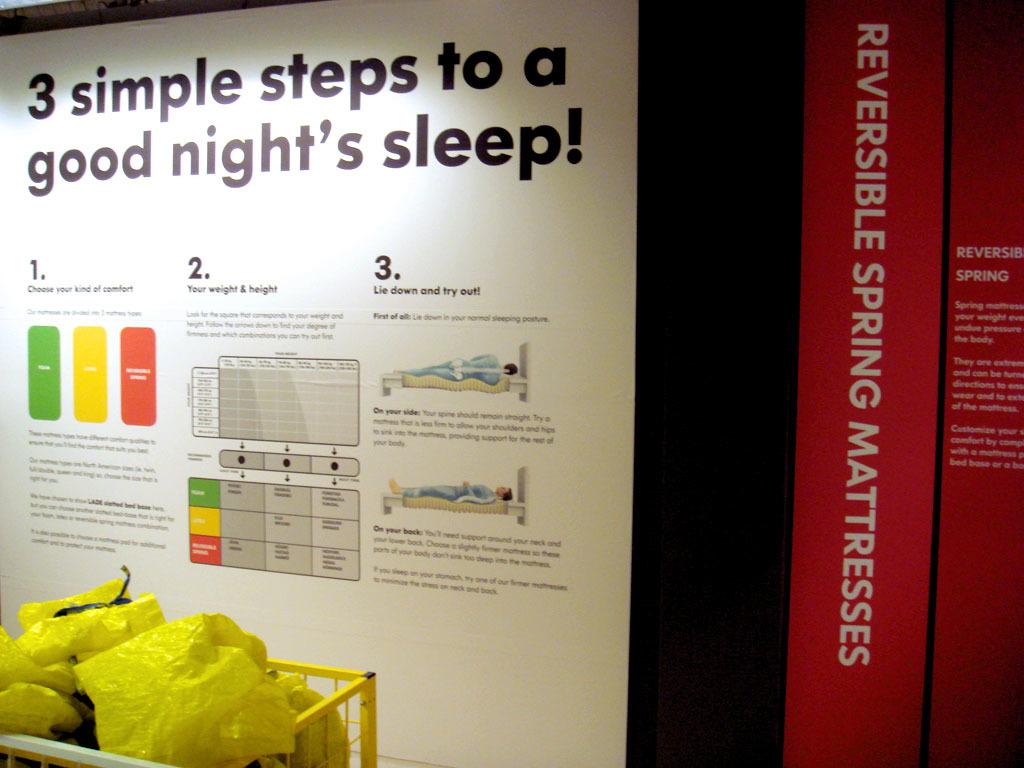What is shown in the white poster?
Keep it short and to the point. 3 simple steps to a good night's sleep. 